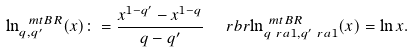<formula> <loc_0><loc_0><loc_500><loc_500>\ln ^ { \ m t { B R } } _ { q , q ^ { \prime } } ( x ) & \colon = \frac { x ^ { 1 - q ^ { \prime } } - x ^ { 1 - q } } { q - q ^ { \prime } } \quad \ r b r { \ln ^ { \ m t { B R } } _ { q \ r a 1 , q ^ { \prime } \ r a 1 } ( x ) = \ln { x } } .</formula> 